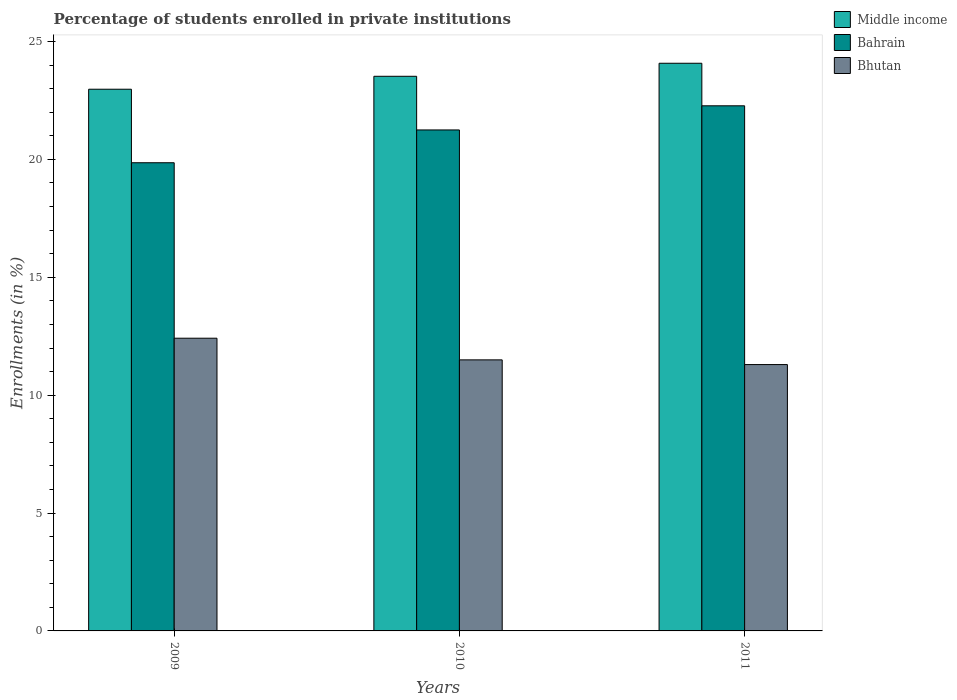How many different coloured bars are there?
Ensure brevity in your answer.  3. How many groups of bars are there?
Your response must be concise. 3. Are the number of bars per tick equal to the number of legend labels?
Ensure brevity in your answer.  Yes. How many bars are there on the 1st tick from the right?
Keep it short and to the point. 3. What is the label of the 2nd group of bars from the left?
Keep it short and to the point. 2010. In how many cases, is the number of bars for a given year not equal to the number of legend labels?
Provide a succinct answer. 0. What is the percentage of trained teachers in Bhutan in 2009?
Make the answer very short. 12.42. Across all years, what is the maximum percentage of trained teachers in Bhutan?
Offer a very short reply. 12.42. Across all years, what is the minimum percentage of trained teachers in Middle income?
Make the answer very short. 22.98. In which year was the percentage of trained teachers in Middle income maximum?
Offer a terse response. 2011. What is the total percentage of trained teachers in Bahrain in the graph?
Provide a succinct answer. 63.38. What is the difference between the percentage of trained teachers in Bhutan in 2009 and that in 2010?
Give a very brief answer. 0.92. What is the difference between the percentage of trained teachers in Bahrain in 2011 and the percentage of trained teachers in Middle income in 2010?
Your answer should be compact. -1.25. What is the average percentage of trained teachers in Middle income per year?
Keep it short and to the point. 23.53. In the year 2009, what is the difference between the percentage of trained teachers in Bahrain and percentage of trained teachers in Middle income?
Provide a short and direct response. -3.12. In how many years, is the percentage of trained teachers in Bahrain greater than 23 %?
Your answer should be compact. 0. What is the ratio of the percentage of trained teachers in Bhutan in 2009 to that in 2010?
Provide a succinct answer. 1.08. What is the difference between the highest and the second highest percentage of trained teachers in Middle income?
Provide a succinct answer. 0.55. What is the difference between the highest and the lowest percentage of trained teachers in Middle income?
Offer a very short reply. 1.1. What does the 2nd bar from the left in 2009 represents?
Offer a terse response. Bahrain. What does the 2nd bar from the right in 2011 represents?
Your answer should be very brief. Bahrain. How many years are there in the graph?
Keep it short and to the point. 3. What is the difference between two consecutive major ticks on the Y-axis?
Your answer should be very brief. 5. Does the graph contain any zero values?
Your response must be concise. No. Does the graph contain grids?
Provide a succinct answer. No. How many legend labels are there?
Offer a very short reply. 3. What is the title of the graph?
Your response must be concise. Percentage of students enrolled in private institutions. Does "Uzbekistan" appear as one of the legend labels in the graph?
Provide a short and direct response. No. What is the label or title of the Y-axis?
Provide a succinct answer. Enrollments (in %). What is the Enrollments (in %) in Middle income in 2009?
Give a very brief answer. 22.98. What is the Enrollments (in %) of Bahrain in 2009?
Make the answer very short. 19.86. What is the Enrollments (in %) in Bhutan in 2009?
Keep it short and to the point. 12.42. What is the Enrollments (in %) in Middle income in 2010?
Offer a terse response. 23.52. What is the Enrollments (in %) in Bahrain in 2010?
Offer a terse response. 21.25. What is the Enrollments (in %) of Bhutan in 2010?
Keep it short and to the point. 11.5. What is the Enrollments (in %) of Middle income in 2011?
Ensure brevity in your answer.  24.08. What is the Enrollments (in %) of Bahrain in 2011?
Offer a very short reply. 22.27. What is the Enrollments (in %) of Bhutan in 2011?
Provide a succinct answer. 11.3. Across all years, what is the maximum Enrollments (in %) of Middle income?
Provide a succinct answer. 24.08. Across all years, what is the maximum Enrollments (in %) of Bahrain?
Provide a short and direct response. 22.27. Across all years, what is the maximum Enrollments (in %) in Bhutan?
Offer a terse response. 12.42. Across all years, what is the minimum Enrollments (in %) in Middle income?
Give a very brief answer. 22.98. Across all years, what is the minimum Enrollments (in %) in Bahrain?
Ensure brevity in your answer.  19.86. Across all years, what is the minimum Enrollments (in %) of Bhutan?
Your answer should be very brief. 11.3. What is the total Enrollments (in %) of Middle income in the graph?
Provide a succinct answer. 70.58. What is the total Enrollments (in %) in Bahrain in the graph?
Offer a terse response. 63.38. What is the total Enrollments (in %) of Bhutan in the graph?
Your answer should be very brief. 35.21. What is the difference between the Enrollments (in %) of Middle income in 2009 and that in 2010?
Your answer should be compact. -0.55. What is the difference between the Enrollments (in %) in Bahrain in 2009 and that in 2010?
Keep it short and to the point. -1.39. What is the difference between the Enrollments (in %) in Bhutan in 2009 and that in 2010?
Provide a short and direct response. 0.92. What is the difference between the Enrollments (in %) of Middle income in 2009 and that in 2011?
Offer a terse response. -1.1. What is the difference between the Enrollments (in %) of Bahrain in 2009 and that in 2011?
Make the answer very short. -2.42. What is the difference between the Enrollments (in %) in Bhutan in 2009 and that in 2011?
Your response must be concise. 1.12. What is the difference between the Enrollments (in %) of Middle income in 2010 and that in 2011?
Your response must be concise. -0.55. What is the difference between the Enrollments (in %) in Bahrain in 2010 and that in 2011?
Provide a short and direct response. -1.02. What is the difference between the Enrollments (in %) in Bhutan in 2010 and that in 2011?
Your answer should be very brief. 0.2. What is the difference between the Enrollments (in %) in Middle income in 2009 and the Enrollments (in %) in Bahrain in 2010?
Keep it short and to the point. 1.73. What is the difference between the Enrollments (in %) in Middle income in 2009 and the Enrollments (in %) in Bhutan in 2010?
Give a very brief answer. 11.48. What is the difference between the Enrollments (in %) in Bahrain in 2009 and the Enrollments (in %) in Bhutan in 2010?
Your answer should be compact. 8.36. What is the difference between the Enrollments (in %) of Middle income in 2009 and the Enrollments (in %) of Bahrain in 2011?
Make the answer very short. 0.7. What is the difference between the Enrollments (in %) in Middle income in 2009 and the Enrollments (in %) in Bhutan in 2011?
Your response must be concise. 11.68. What is the difference between the Enrollments (in %) in Bahrain in 2009 and the Enrollments (in %) in Bhutan in 2011?
Ensure brevity in your answer.  8.56. What is the difference between the Enrollments (in %) of Middle income in 2010 and the Enrollments (in %) of Bahrain in 2011?
Give a very brief answer. 1.25. What is the difference between the Enrollments (in %) in Middle income in 2010 and the Enrollments (in %) in Bhutan in 2011?
Give a very brief answer. 12.23. What is the difference between the Enrollments (in %) in Bahrain in 2010 and the Enrollments (in %) in Bhutan in 2011?
Provide a short and direct response. 9.95. What is the average Enrollments (in %) of Middle income per year?
Your answer should be compact. 23.53. What is the average Enrollments (in %) of Bahrain per year?
Ensure brevity in your answer.  21.13. What is the average Enrollments (in %) in Bhutan per year?
Give a very brief answer. 11.74. In the year 2009, what is the difference between the Enrollments (in %) of Middle income and Enrollments (in %) of Bahrain?
Your answer should be very brief. 3.12. In the year 2009, what is the difference between the Enrollments (in %) in Middle income and Enrollments (in %) in Bhutan?
Provide a short and direct response. 10.56. In the year 2009, what is the difference between the Enrollments (in %) of Bahrain and Enrollments (in %) of Bhutan?
Provide a succinct answer. 7.44. In the year 2010, what is the difference between the Enrollments (in %) of Middle income and Enrollments (in %) of Bahrain?
Make the answer very short. 2.28. In the year 2010, what is the difference between the Enrollments (in %) of Middle income and Enrollments (in %) of Bhutan?
Your answer should be compact. 12.03. In the year 2010, what is the difference between the Enrollments (in %) in Bahrain and Enrollments (in %) in Bhutan?
Your answer should be compact. 9.75. In the year 2011, what is the difference between the Enrollments (in %) of Middle income and Enrollments (in %) of Bahrain?
Your response must be concise. 1.8. In the year 2011, what is the difference between the Enrollments (in %) in Middle income and Enrollments (in %) in Bhutan?
Your answer should be compact. 12.78. In the year 2011, what is the difference between the Enrollments (in %) of Bahrain and Enrollments (in %) of Bhutan?
Make the answer very short. 10.98. What is the ratio of the Enrollments (in %) of Middle income in 2009 to that in 2010?
Give a very brief answer. 0.98. What is the ratio of the Enrollments (in %) of Bahrain in 2009 to that in 2010?
Keep it short and to the point. 0.93. What is the ratio of the Enrollments (in %) of Bhutan in 2009 to that in 2010?
Provide a succinct answer. 1.08. What is the ratio of the Enrollments (in %) in Middle income in 2009 to that in 2011?
Offer a terse response. 0.95. What is the ratio of the Enrollments (in %) of Bahrain in 2009 to that in 2011?
Ensure brevity in your answer.  0.89. What is the ratio of the Enrollments (in %) of Bhutan in 2009 to that in 2011?
Provide a succinct answer. 1.1. What is the ratio of the Enrollments (in %) of Bahrain in 2010 to that in 2011?
Provide a short and direct response. 0.95. What is the ratio of the Enrollments (in %) of Bhutan in 2010 to that in 2011?
Ensure brevity in your answer.  1.02. What is the difference between the highest and the second highest Enrollments (in %) in Middle income?
Give a very brief answer. 0.55. What is the difference between the highest and the second highest Enrollments (in %) in Bhutan?
Ensure brevity in your answer.  0.92. What is the difference between the highest and the lowest Enrollments (in %) of Middle income?
Keep it short and to the point. 1.1. What is the difference between the highest and the lowest Enrollments (in %) of Bahrain?
Keep it short and to the point. 2.42. What is the difference between the highest and the lowest Enrollments (in %) of Bhutan?
Your answer should be compact. 1.12. 